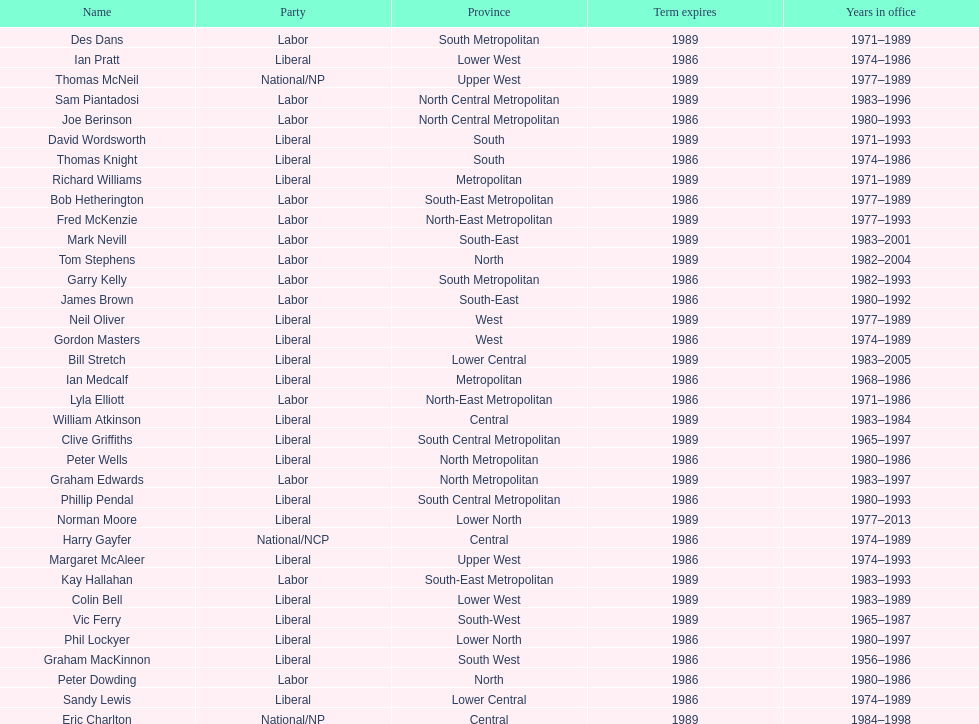What is the complete sum of members whose term finishes in 1989? 9. 